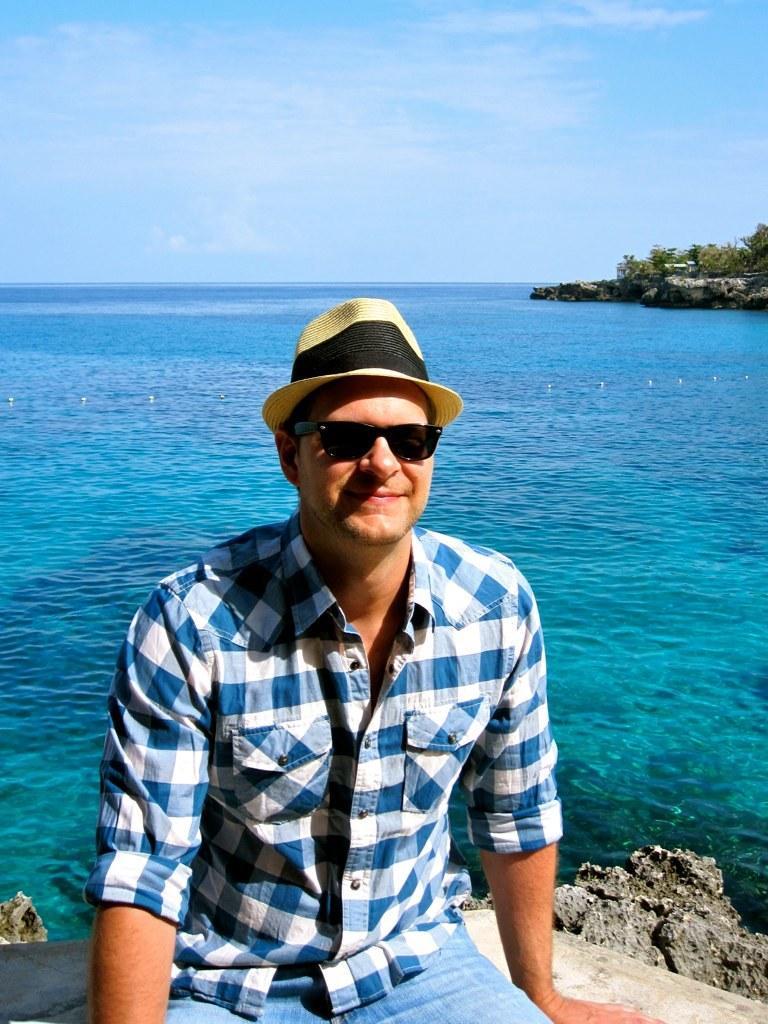In one or two sentences, can you explain what this image depicts? In this image, we can see a person wearing goggles and hat. He is smiling and sitting on the surface. Background we can see wall, trees, rocks, water and sky. 